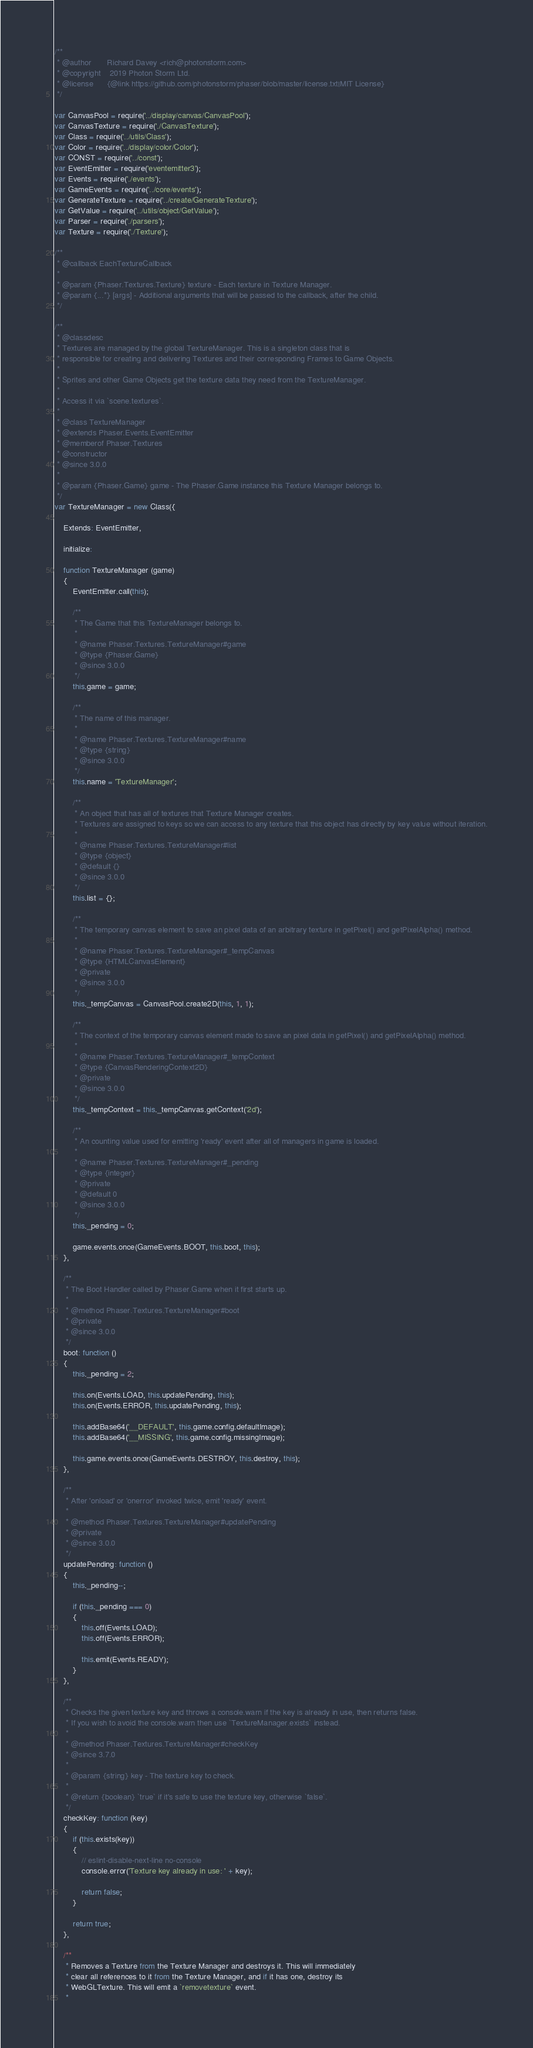Convert code to text. <code><loc_0><loc_0><loc_500><loc_500><_JavaScript_>/**
 * @author       Richard Davey <rich@photonstorm.com>
 * @copyright    2019 Photon Storm Ltd.
 * @license      {@link https://github.com/photonstorm/phaser/blob/master/license.txt|MIT License}
 */

var CanvasPool = require('../display/canvas/CanvasPool');
var CanvasTexture = require('./CanvasTexture');
var Class = require('../utils/Class');
var Color = require('../display/color/Color');
var CONST = require('../const');
var EventEmitter = require('eventemitter3');
var Events = require('./events');
var GameEvents = require('../core/events');
var GenerateTexture = require('../create/GenerateTexture');
var GetValue = require('../utils/object/GetValue');
var Parser = require('./parsers');
var Texture = require('./Texture');

/**
 * @callback EachTextureCallback
 *
 * @param {Phaser.Textures.Texture} texture - Each texture in Texture Manager.
 * @param {...*} [args] - Additional arguments that will be passed to the callback, after the child.
 */

/**
 * @classdesc
 * Textures are managed by the global TextureManager. This is a singleton class that is
 * responsible for creating and delivering Textures and their corresponding Frames to Game Objects.
 *
 * Sprites and other Game Objects get the texture data they need from the TextureManager.
 *
 * Access it via `scene.textures`.
 *
 * @class TextureManager
 * @extends Phaser.Events.EventEmitter
 * @memberof Phaser.Textures
 * @constructor
 * @since 3.0.0
 *
 * @param {Phaser.Game} game - The Phaser.Game instance this Texture Manager belongs to.
 */
var TextureManager = new Class({

    Extends: EventEmitter,

    initialize:

    function TextureManager (game)
    {
        EventEmitter.call(this);

        /**
         * The Game that this TextureManager belongs to.
         *
         * @name Phaser.Textures.TextureManager#game
         * @type {Phaser.Game}
         * @since 3.0.0
         */
        this.game = game;

        /**
         * The name of this manager.
         *
         * @name Phaser.Textures.TextureManager#name
         * @type {string}
         * @since 3.0.0
         */
        this.name = 'TextureManager';

        /**
         * An object that has all of textures that Texture Manager creates.
         * Textures are assigned to keys so we can access to any texture that this object has directly by key value without iteration.
         *
         * @name Phaser.Textures.TextureManager#list
         * @type {object}
         * @default {}
         * @since 3.0.0
         */
        this.list = {};

        /**
         * The temporary canvas element to save an pixel data of an arbitrary texture in getPixel() and getPixelAlpha() method.
         *
         * @name Phaser.Textures.TextureManager#_tempCanvas
         * @type {HTMLCanvasElement}
         * @private
         * @since 3.0.0
         */
        this._tempCanvas = CanvasPool.create2D(this, 1, 1);

        /**
         * The context of the temporary canvas element made to save an pixel data in getPixel() and getPixelAlpha() method.
         *
         * @name Phaser.Textures.TextureManager#_tempContext
         * @type {CanvasRenderingContext2D}
         * @private
         * @since 3.0.0
         */
        this._tempContext = this._tempCanvas.getContext('2d');

        /**
         * An counting value used for emitting 'ready' event after all of managers in game is loaded.
         *
         * @name Phaser.Textures.TextureManager#_pending
         * @type {integer}
         * @private
         * @default 0
         * @since 3.0.0
         */
        this._pending = 0;

        game.events.once(GameEvents.BOOT, this.boot, this);
    },

    /**
     * The Boot Handler called by Phaser.Game when it first starts up.
     *
     * @method Phaser.Textures.TextureManager#boot
     * @private
     * @since 3.0.0
     */
    boot: function ()
    {
        this._pending = 2;

        this.on(Events.LOAD, this.updatePending, this);
        this.on(Events.ERROR, this.updatePending, this);

        this.addBase64('__DEFAULT', this.game.config.defaultImage);
        this.addBase64('__MISSING', this.game.config.missingImage);

        this.game.events.once(GameEvents.DESTROY, this.destroy, this);
    },

    /**
     * After 'onload' or 'onerror' invoked twice, emit 'ready' event.
     *
     * @method Phaser.Textures.TextureManager#updatePending
     * @private
     * @since 3.0.0
     */
    updatePending: function ()
    {
        this._pending--;

        if (this._pending === 0)
        {
            this.off(Events.LOAD);
            this.off(Events.ERROR);

            this.emit(Events.READY);
        }
    },

    /**
     * Checks the given texture key and throws a console.warn if the key is already in use, then returns false.
     * If you wish to avoid the console.warn then use `TextureManager.exists` instead.
     *
     * @method Phaser.Textures.TextureManager#checkKey
     * @since 3.7.0
     *
     * @param {string} key - The texture key to check.
     *
     * @return {boolean} `true` if it's safe to use the texture key, otherwise `false`.
     */
    checkKey: function (key)
    {
        if (this.exists(key))
        {
            // eslint-disable-next-line no-console
            console.error('Texture key already in use: ' + key);

            return false;
        }

        return true;
    },

    /**
     * Removes a Texture from the Texture Manager and destroys it. This will immediately
     * clear all references to it from the Texture Manager, and if it has one, destroy its
     * WebGLTexture. This will emit a `removetexture` event.
     *</code> 